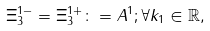<formula> <loc_0><loc_0><loc_500><loc_500>\Xi _ { 3 } ^ { 1 - } = \Xi _ { 3 } ^ { 1 + } \colon = A ^ { 1 } ; \forall k _ { 1 } \in \mathbb { R } ,</formula> 